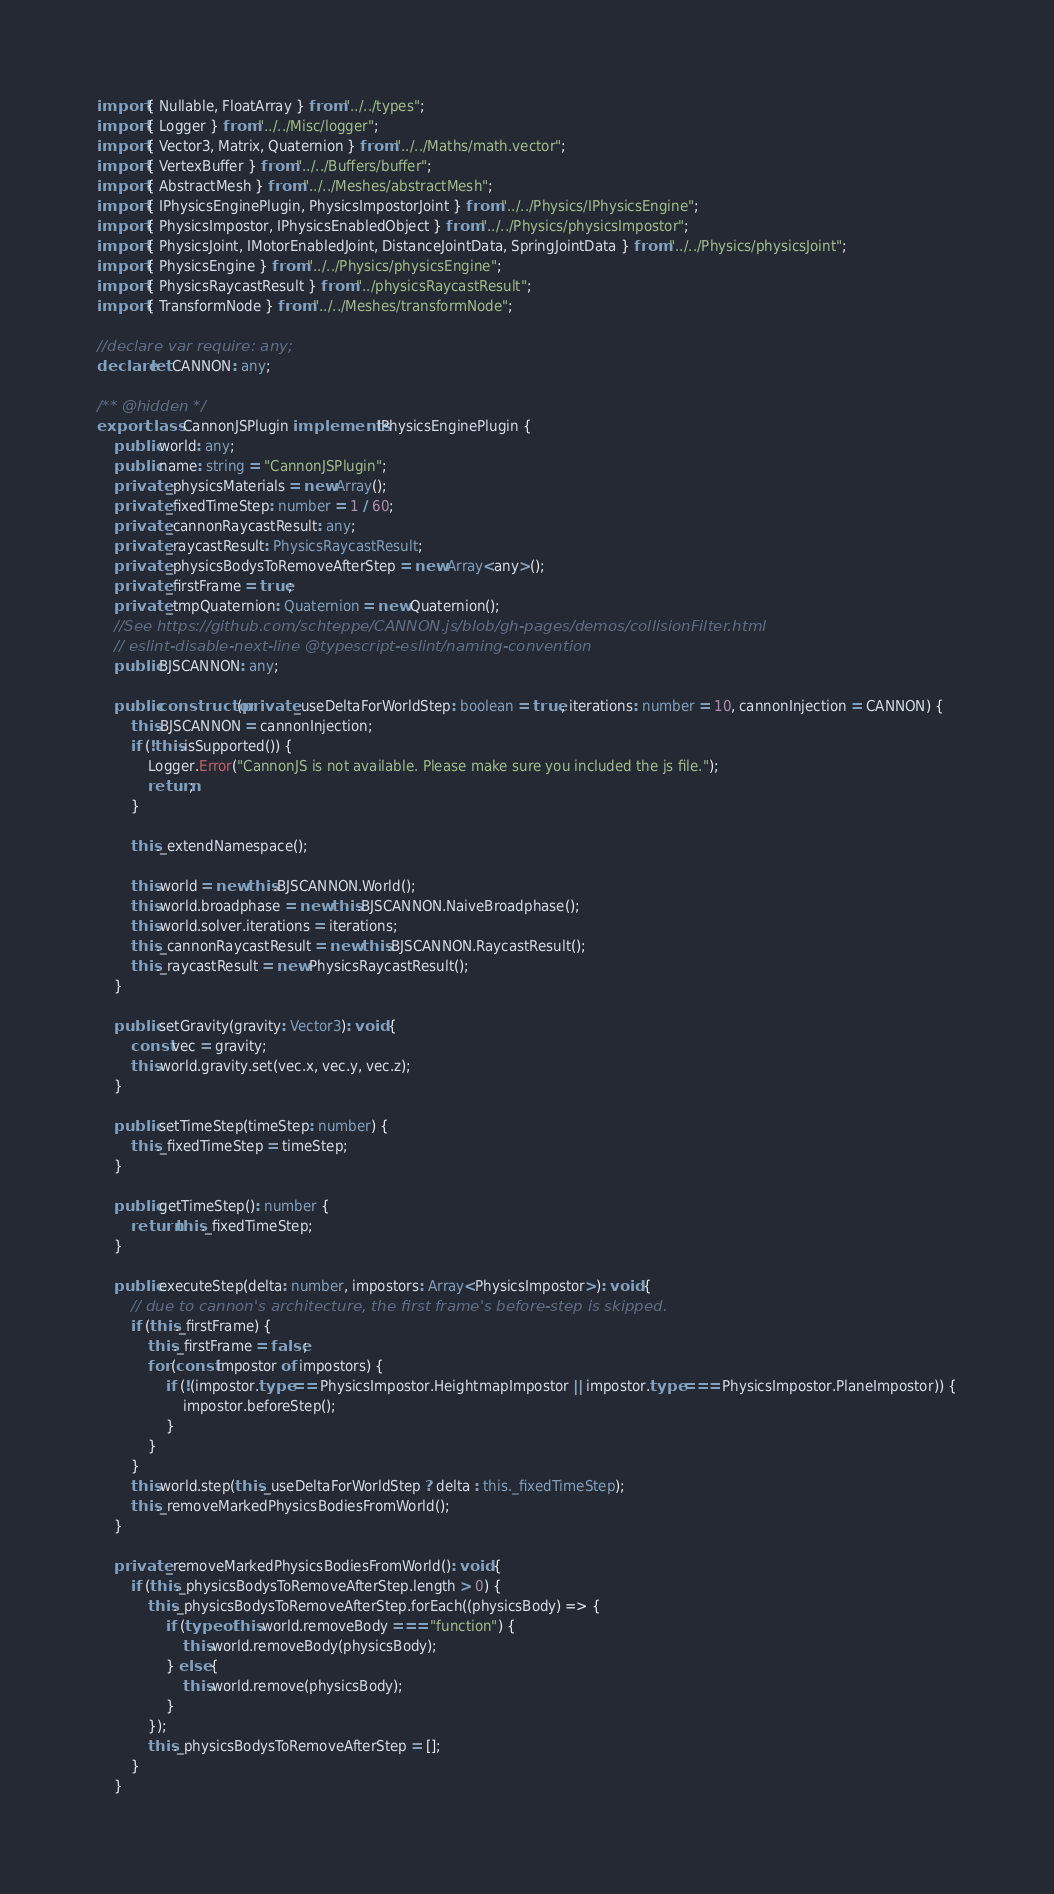Convert code to text. <code><loc_0><loc_0><loc_500><loc_500><_TypeScript_>import { Nullable, FloatArray } from "../../types";
import { Logger } from "../../Misc/logger";
import { Vector3, Matrix, Quaternion } from "../../Maths/math.vector";
import { VertexBuffer } from "../../Buffers/buffer";
import { AbstractMesh } from "../../Meshes/abstractMesh";
import { IPhysicsEnginePlugin, PhysicsImpostorJoint } from "../../Physics/IPhysicsEngine";
import { PhysicsImpostor, IPhysicsEnabledObject } from "../../Physics/physicsImpostor";
import { PhysicsJoint, IMotorEnabledJoint, DistanceJointData, SpringJointData } from "../../Physics/physicsJoint";
import { PhysicsEngine } from "../../Physics/physicsEngine";
import { PhysicsRaycastResult } from "../physicsRaycastResult";
import { TransformNode } from "../../Meshes/transformNode";

//declare var require: any;
declare let CANNON: any;

/** @hidden */
export class CannonJSPlugin implements IPhysicsEnginePlugin {
    public world: any;
    public name: string = "CannonJSPlugin";
    private _physicsMaterials = new Array();
    private _fixedTimeStep: number = 1 / 60;
    private _cannonRaycastResult: any;
    private _raycastResult: PhysicsRaycastResult;
    private _physicsBodysToRemoveAfterStep = new Array<any>();
    private _firstFrame = true;
    private _tmpQuaternion: Quaternion = new Quaternion();
    //See https://github.com/schteppe/CANNON.js/blob/gh-pages/demos/collisionFilter.html
    // eslint-disable-next-line @typescript-eslint/naming-convention
    public BJSCANNON: any;

    public constructor(private _useDeltaForWorldStep: boolean = true, iterations: number = 10, cannonInjection = CANNON) {
        this.BJSCANNON = cannonInjection;
        if (!this.isSupported()) {
            Logger.Error("CannonJS is not available. Please make sure you included the js file.");
            return;
        }

        this._extendNamespace();

        this.world = new this.BJSCANNON.World();
        this.world.broadphase = new this.BJSCANNON.NaiveBroadphase();
        this.world.solver.iterations = iterations;
        this._cannonRaycastResult = new this.BJSCANNON.RaycastResult();
        this._raycastResult = new PhysicsRaycastResult();
    }

    public setGravity(gravity: Vector3): void {
        const vec = gravity;
        this.world.gravity.set(vec.x, vec.y, vec.z);
    }

    public setTimeStep(timeStep: number) {
        this._fixedTimeStep = timeStep;
    }

    public getTimeStep(): number {
        return this._fixedTimeStep;
    }

    public executeStep(delta: number, impostors: Array<PhysicsImpostor>): void {
        // due to cannon's architecture, the first frame's before-step is skipped.
        if (this._firstFrame) {
            this._firstFrame = false;
            for (const impostor of impostors) {
                if (!(impostor.type == PhysicsImpostor.HeightmapImpostor || impostor.type === PhysicsImpostor.PlaneImpostor)) {
                    impostor.beforeStep();
                }
            }
        }
        this.world.step(this._useDeltaForWorldStep ? delta : this._fixedTimeStep);
        this._removeMarkedPhysicsBodiesFromWorld();
    }

    private _removeMarkedPhysicsBodiesFromWorld(): void {
        if (this._physicsBodysToRemoveAfterStep.length > 0) {
            this._physicsBodysToRemoveAfterStep.forEach((physicsBody) => {
                if (typeof this.world.removeBody === "function") {
                    this.world.removeBody(physicsBody);
                } else {
                    this.world.remove(physicsBody);
                }
            });
            this._physicsBodysToRemoveAfterStep = [];
        }
    }
</code> 